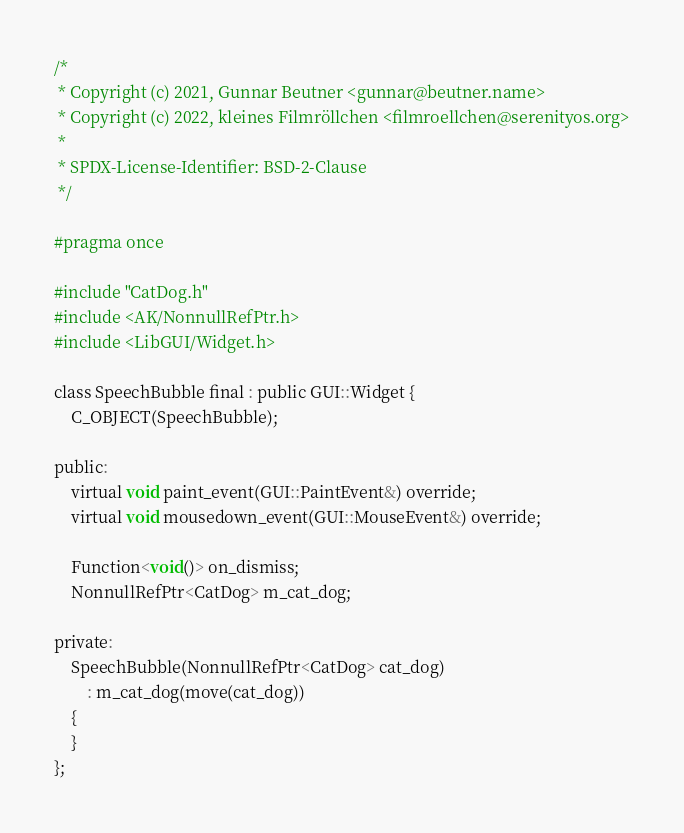<code> <loc_0><loc_0><loc_500><loc_500><_C_>/*
 * Copyright (c) 2021, Gunnar Beutner <gunnar@beutner.name>
 * Copyright (c) 2022, kleines Filmröllchen <filmroellchen@serenityos.org>
 *
 * SPDX-License-Identifier: BSD-2-Clause
 */

#pragma once

#include "CatDog.h"
#include <AK/NonnullRefPtr.h>
#include <LibGUI/Widget.h>

class SpeechBubble final : public GUI::Widget {
    C_OBJECT(SpeechBubble);

public:
    virtual void paint_event(GUI::PaintEvent&) override;
    virtual void mousedown_event(GUI::MouseEvent&) override;

    Function<void()> on_dismiss;
    NonnullRefPtr<CatDog> m_cat_dog;

private:
    SpeechBubble(NonnullRefPtr<CatDog> cat_dog)
        : m_cat_dog(move(cat_dog))
    {
    }
};
</code> 